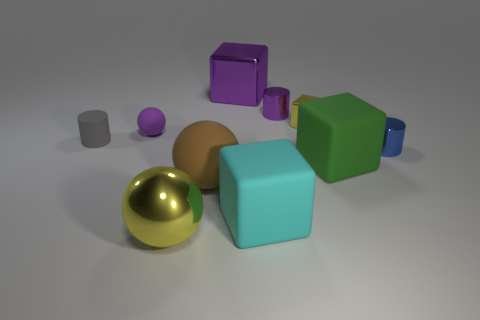Subtract all purple blocks. Subtract all blue cylinders. How many blocks are left? 3 Subtract all cubes. How many objects are left? 6 Add 7 purple matte spheres. How many purple matte spheres exist? 8 Subtract 0 red spheres. How many objects are left? 10 Subtract all small purple objects. Subtract all yellow metallic cubes. How many objects are left? 7 Add 6 large metallic blocks. How many large metallic blocks are left? 7 